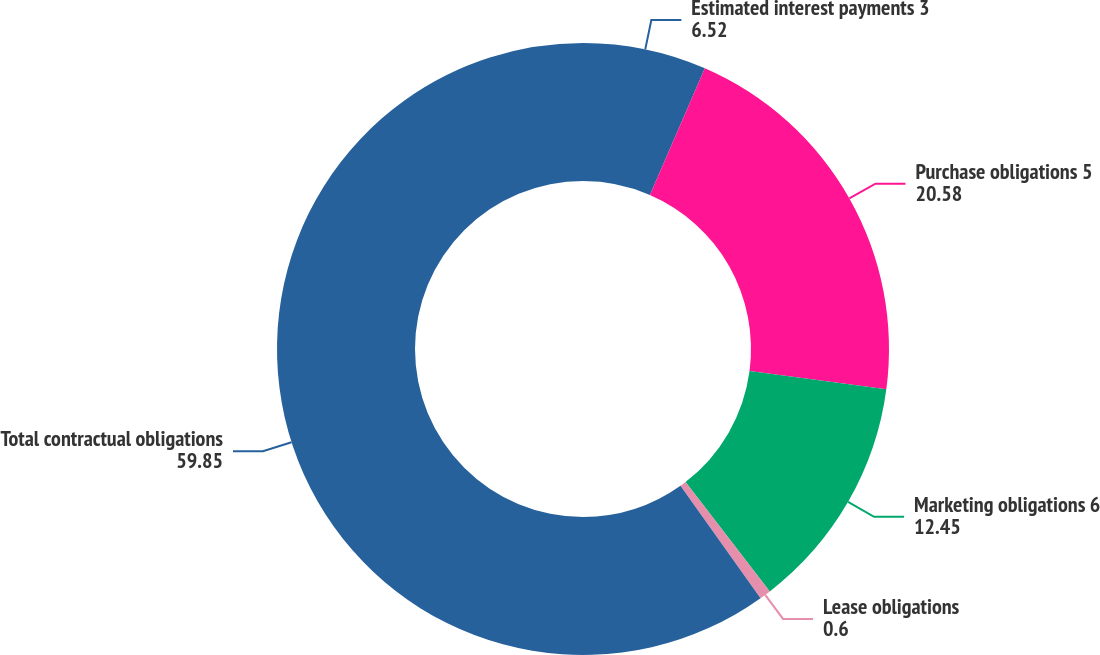<chart> <loc_0><loc_0><loc_500><loc_500><pie_chart><fcel>Estimated interest payments 3<fcel>Purchase obligations 5<fcel>Marketing obligations 6<fcel>Lease obligations<fcel>Total contractual obligations<nl><fcel>6.52%<fcel>20.58%<fcel>12.45%<fcel>0.6%<fcel>59.85%<nl></chart> 